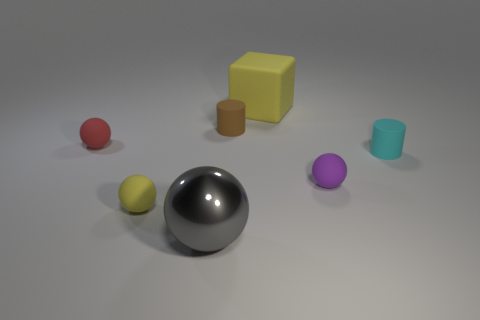Subtract all purple balls. How many balls are left? 3 Subtract all purple spheres. How many spheres are left? 3 Add 1 tiny yellow things. How many objects exist? 8 Subtract all brown balls. Subtract all red blocks. How many balls are left? 4 Subtract all cylinders. How many objects are left? 5 Add 6 big red metallic spheres. How many big red metallic spheres exist? 6 Subtract 1 cyan cylinders. How many objects are left? 6 Subtract all big rubber cubes. Subtract all small yellow balls. How many objects are left? 5 Add 6 tiny red objects. How many tiny red objects are left? 7 